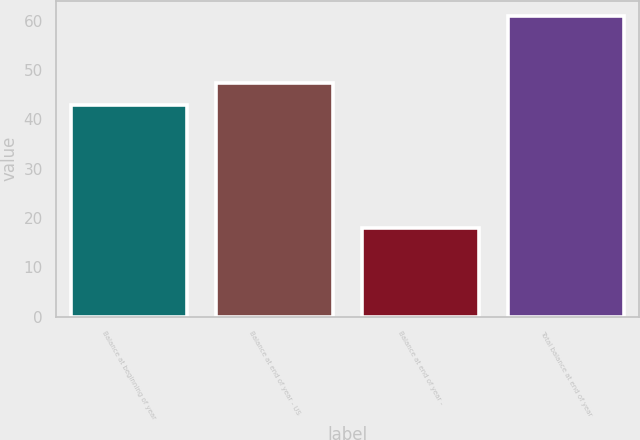<chart> <loc_0><loc_0><loc_500><loc_500><bar_chart><fcel>Balance at beginning of year<fcel>Balance at end of year - US<fcel>Balance at end of year -<fcel>Total balance at end of year<nl><fcel>43<fcel>47.3<fcel>18<fcel>61<nl></chart> 